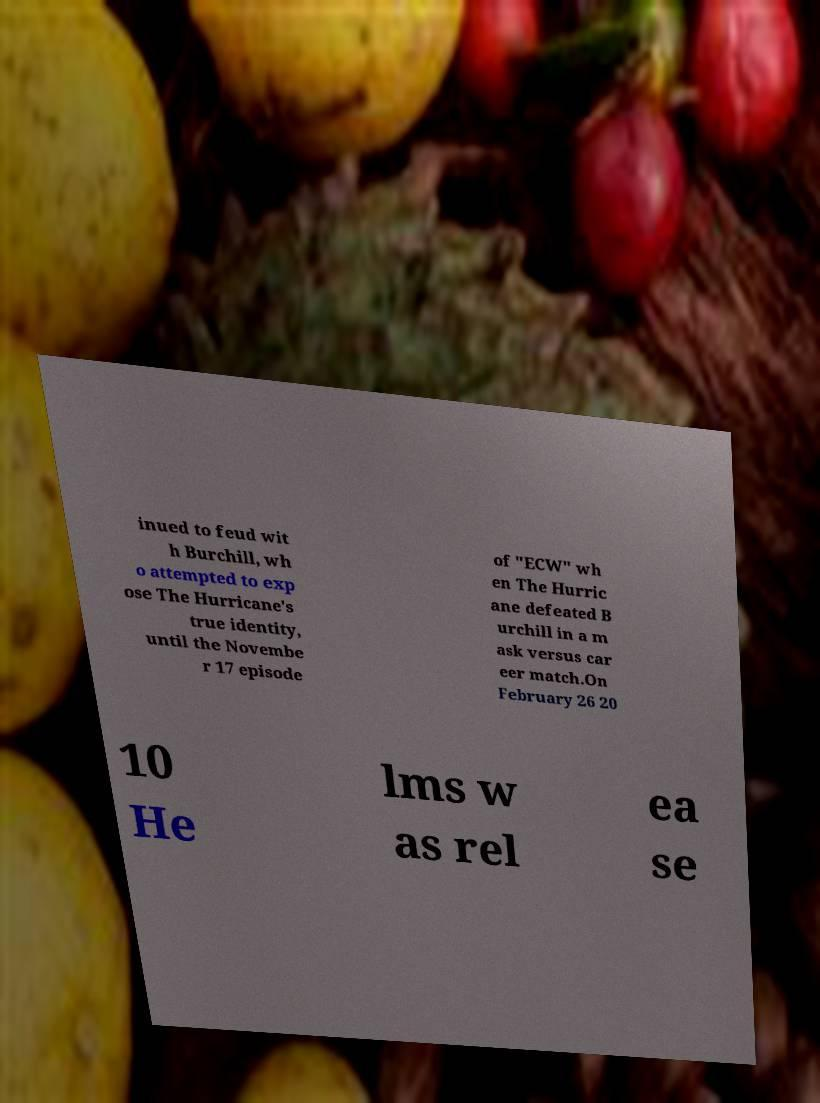For documentation purposes, I need the text within this image transcribed. Could you provide that? inued to feud wit h Burchill, wh o attempted to exp ose The Hurricane's true identity, until the Novembe r 17 episode of "ECW" wh en The Hurric ane defeated B urchill in a m ask versus car eer match.On February 26 20 10 He lms w as rel ea se 